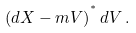<formula> <loc_0><loc_0><loc_500><loc_500>\left ( d X - m V \right ) ^ { ^ { * } } d V \, .</formula> 